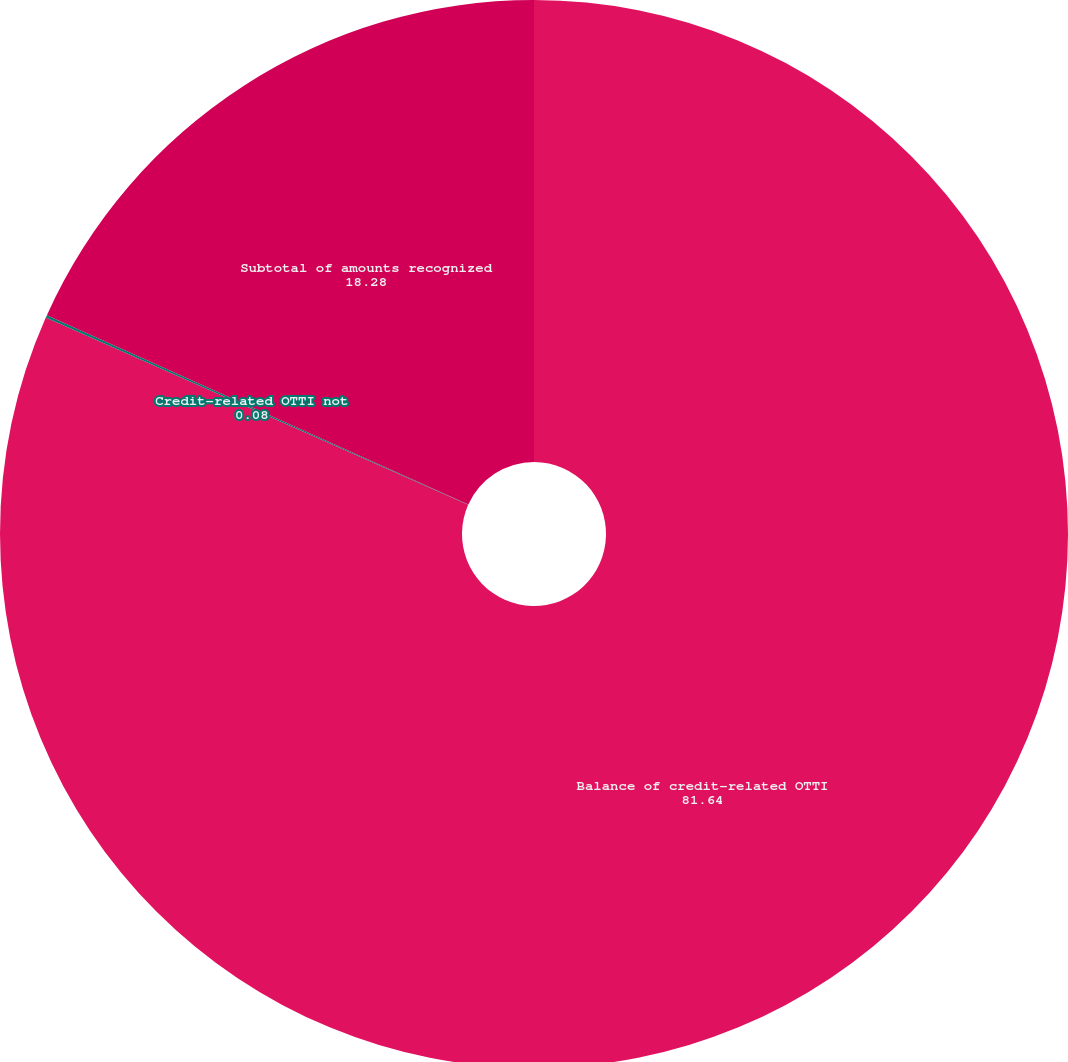<chart> <loc_0><loc_0><loc_500><loc_500><pie_chart><fcel>Balance of credit-related OTTI<fcel>Credit-related OTTI not<fcel>Subtotal of amounts recognized<nl><fcel>81.64%<fcel>0.08%<fcel>18.28%<nl></chart> 